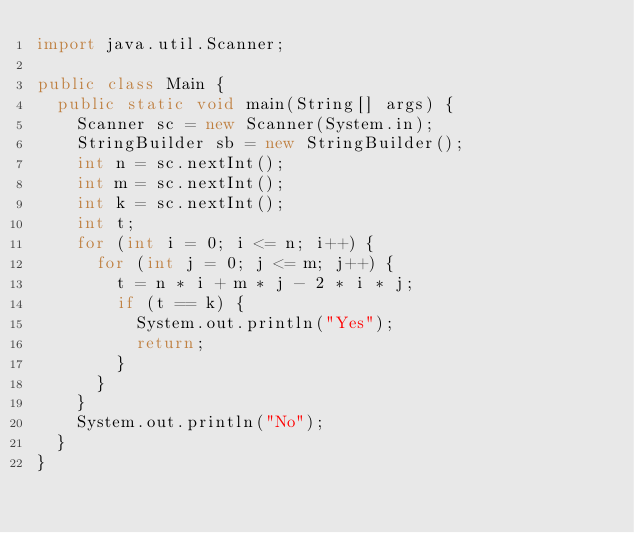<code> <loc_0><loc_0><loc_500><loc_500><_Java_>import java.util.Scanner;

public class Main {
	public static void main(String[] args) {
		Scanner sc = new Scanner(System.in);
		StringBuilder sb = new StringBuilder();
		int n = sc.nextInt();
		int m = sc.nextInt();
		int k = sc.nextInt();
		int t;
		for (int i = 0; i <= n; i++) {
			for (int j = 0; j <= m; j++) {
				t = n * i + m * j - 2 * i * j;
				if (t == k) {
					System.out.println("Yes");
					return;
				}
			}
		}
		System.out.println("No");
	}
}</code> 